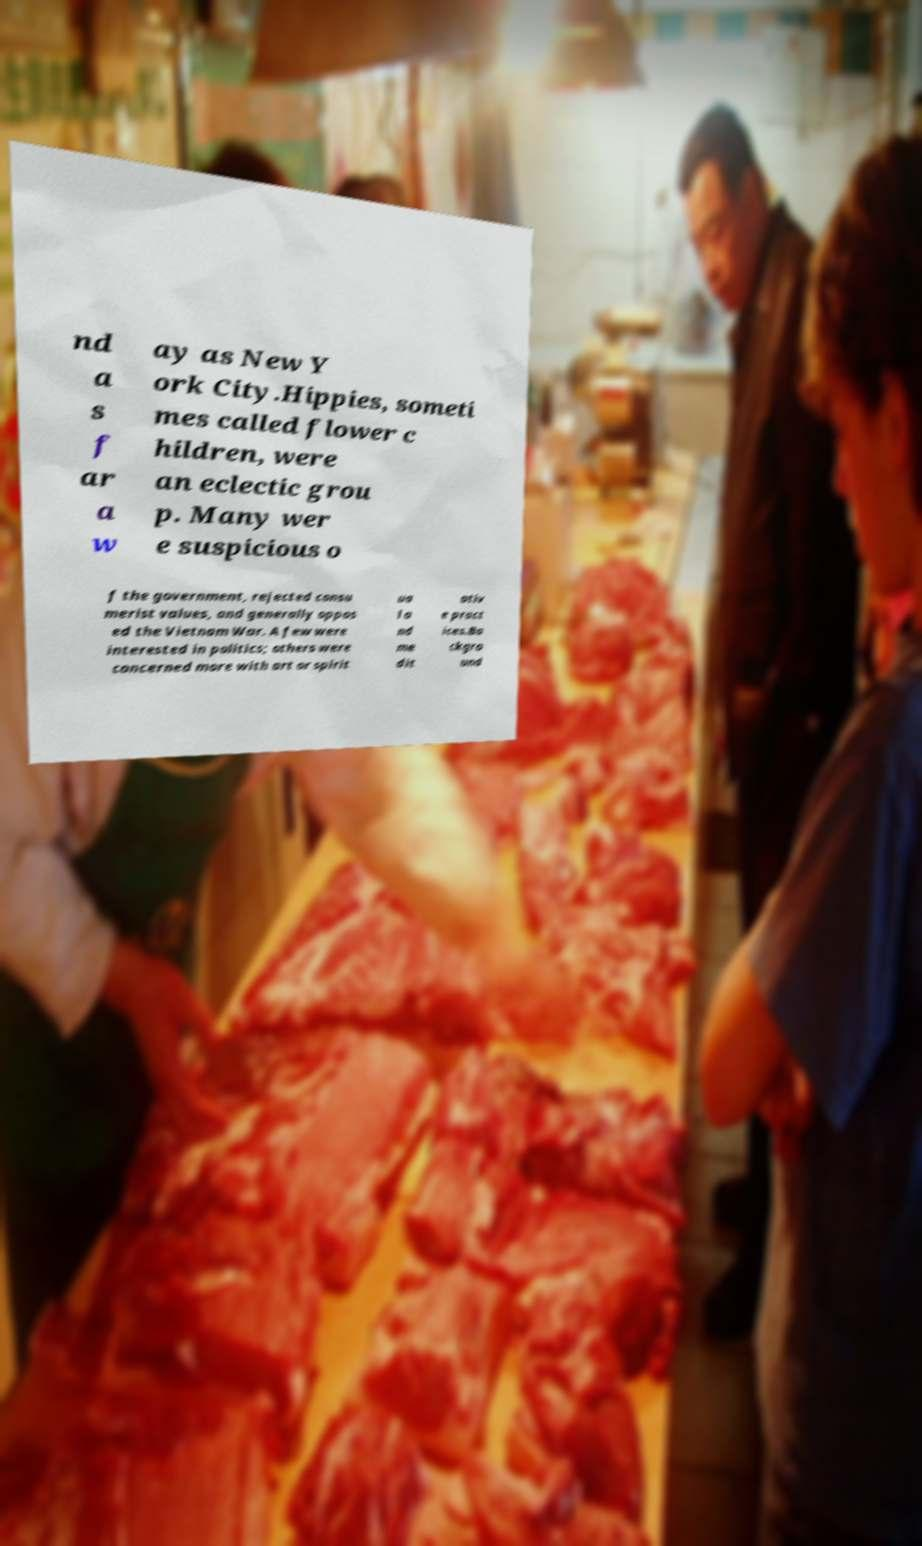Can you accurately transcribe the text from the provided image for me? nd a s f ar a w ay as New Y ork City.Hippies, someti mes called flower c hildren, were an eclectic grou p. Many wer e suspicious o f the government, rejected consu merist values, and generally oppos ed the Vietnam War. A few were interested in politics; others were concerned more with art or spirit ua l a nd me dit ativ e pract ices.Ba ckgro und 